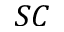Convert formula to latex. <formula><loc_0><loc_0><loc_500><loc_500>S C</formula> 